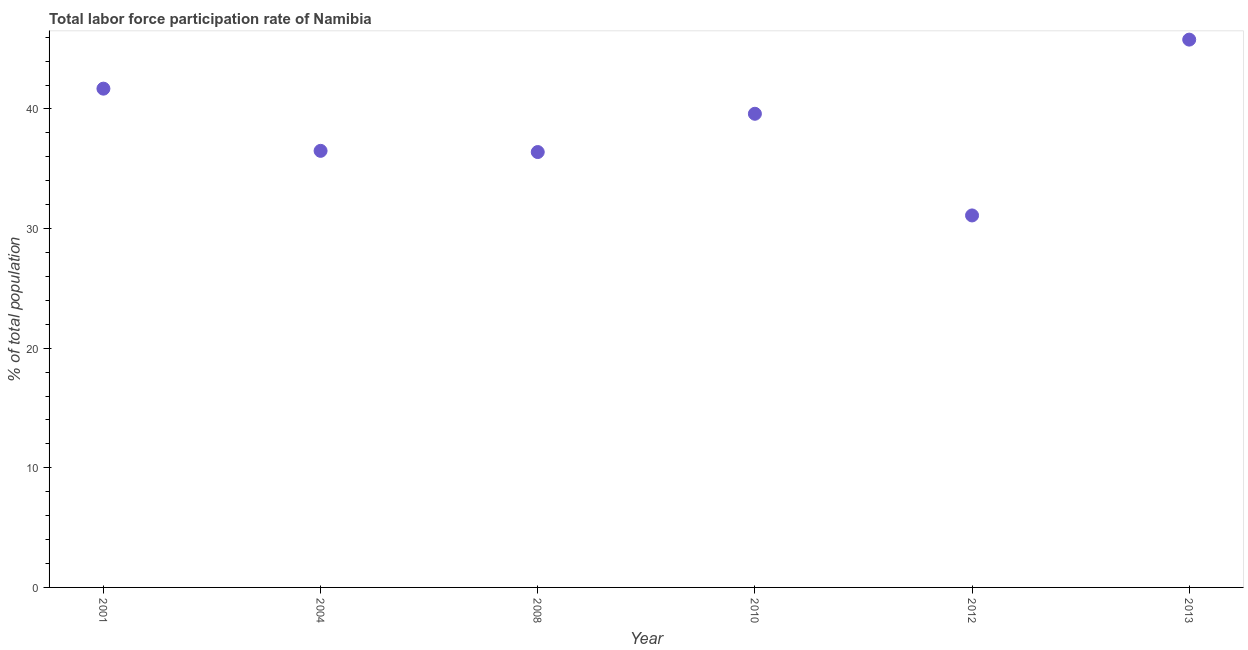What is the total labor force participation rate in 2012?
Keep it short and to the point. 31.1. Across all years, what is the maximum total labor force participation rate?
Offer a terse response. 45.8. Across all years, what is the minimum total labor force participation rate?
Your answer should be very brief. 31.1. In which year was the total labor force participation rate maximum?
Give a very brief answer. 2013. What is the sum of the total labor force participation rate?
Give a very brief answer. 231.1. What is the difference between the total labor force participation rate in 2004 and 2012?
Ensure brevity in your answer.  5.4. What is the average total labor force participation rate per year?
Provide a short and direct response. 38.52. What is the median total labor force participation rate?
Provide a short and direct response. 38.05. In how many years, is the total labor force participation rate greater than 30 %?
Give a very brief answer. 6. What is the ratio of the total labor force participation rate in 2010 to that in 2012?
Make the answer very short. 1.27. Is the total labor force participation rate in 2001 less than that in 2012?
Your response must be concise. No. What is the difference between the highest and the second highest total labor force participation rate?
Provide a succinct answer. 4.1. Is the sum of the total labor force participation rate in 2001 and 2012 greater than the maximum total labor force participation rate across all years?
Your answer should be compact. Yes. What is the difference between the highest and the lowest total labor force participation rate?
Ensure brevity in your answer.  14.7. Does the total labor force participation rate monotonically increase over the years?
Give a very brief answer. No. How many dotlines are there?
Offer a very short reply. 1. How many years are there in the graph?
Offer a terse response. 6. What is the title of the graph?
Make the answer very short. Total labor force participation rate of Namibia. What is the label or title of the Y-axis?
Your answer should be very brief. % of total population. What is the % of total population in 2001?
Your answer should be compact. 41.7. What is the % of total population in 2004?
Your answer should be very brief. 36.5. What is the % of total population in 2008?
Provide a succinct answer. 36.4. What is the % of total population in 2010?
Your answer should be compact. 39.6. What is the % of total population in 2012?
Offer a terse response. 31.1. What is the % of total population in 2013?
Offer a very short reply. 45.8. What is the difference between the % of total population in 2001 and 2010?
Keep it short and to the point. 2.1. What is the difference between the % of total population in 2001 and 2013?
Offer a very short reply. -4.1. What is the difference between the % of total population in 2004 and 2010?
Provide a succinct answer. -3.1. What is the difference between the % of total population in 2004 and 2012?
Ensure brevity in your answer.  5.4. What is the difference between the % of total population in 2004 and 2013?
Provide a succinct answer. -9.3. What is the difference between the % of total population in 2008 and 2010?
Offer a terse response. -3.2. What is the difference between the % of total population in 2008 and 2013?
Your answer should be very brief. -9.4. What is the difference between the % of total population in 2010 and 2012?
Ensure brevity in your answer.  8.5. What is the difference between the % of total population in 2010 and 2013?
Give a very brief answer. -6.2. What is the difference between the % of total population in 2012 and 2013?
Your answer should be compact. -14.7. What is the ratio of the % of total population in 2001 to that in 2004?
Provide a succinct answer. 1.14. What is the ratio of the % of total population in 2001 to that in 2008?
Your answer should be very brief. 1.15. What is the ratio of the % of total population in 2001 to that in 2010?
Provide a succinct answer. 1.05. What is the ratio of the % of total population in 2001 to that in 2012?
Your response must be concise. 1.34. What is the ratio of the % of total population in 2001 to that in 2013?
Make the answer very short. 0.91. What is the ratio of the % of total population in 2004 to that in 2010?
Offer a very short reply. 0.92. What is the ratio of the % of total population in 2004 to that in 2012?
Offer a terse response. 1.17. What is the ratio of the % of total population in 2004 to that in 2013?
Your response must be concise. 0.8. What is the ratio of the % of total population in 2008 to that in 2010?
Offer a very short reply. 0.92. What is the ratio of the % of total population in 2008 to that in 2012?
Your answer should be compact. 1.17. What is the ratio of the % of total population in 2008 to that in 2013?
Ensure brevity in your answer.  0.8. What is the ratio of the % of total population in 2010 to that in 2012?
Ensure brevity in your answer.  1.27. What is the ratio of the % of total population in 2010 to that in 2013?
Provide a short and direct response. 0.86. What is the ratio of the % of total population in 2012 to that in 2013?
Offer a terse response. 0.68. 